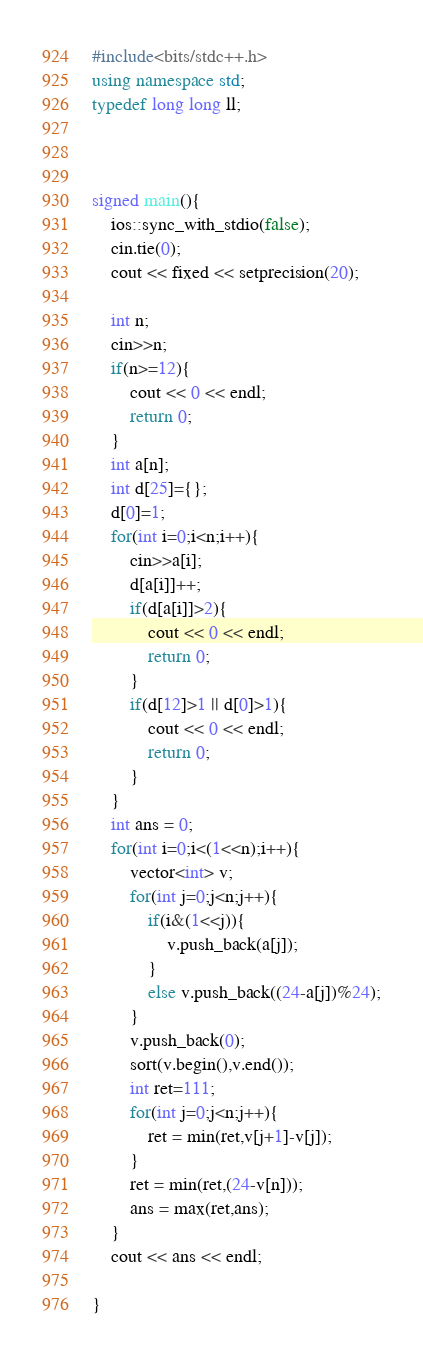Convert code to text. <code><loc_0><loc_0><loc_500><loc_500><_C++_>#include<bits/stdc++.h>
using namespace std;
typedef long long ll;



signed main(){
    ios::sync_with_stdio(false);
    cin.tie(0);
    cout << fixed << setprecision(20);
    
    int n;
    cin>>n;
    if(n>=12){
        cout << 0 << endl;
        return 0;
    }
    int a[n];
    int d[25]={};
    d[0]=1;
    for(int i=0;i<n;i++){
        cin>>a[i];
        d[a[i]]++;
        if(d[a[i]]>2){
            cout << 0 << endl;
            return 0;
        }
        if(d[12]>1 || d[0]>1){
            cout << 0 << endl;
            return 0;
        }
    }    
    int ans = 0;
    for(int i=0;i<(1<<n);i++){
        vector<int> v;
        for(int j=0;j<n;j++){
            if(i&(1<<j)){
                v.push_back(a[j]);
            }
            else v.push_back((24-a[j])%24);
        }
        v.push_back(0);
        sort(v.begin(),v.end());
        int ret=111;
        for(int j=0;j<n;j++){
            ret = min(ret,v[j+1]-v[j]);
        }
        ret = min(ret,(24-v[n]));
        ans = max(ret,ans);
    }
    cout << ans << endl;
    
}</code> 